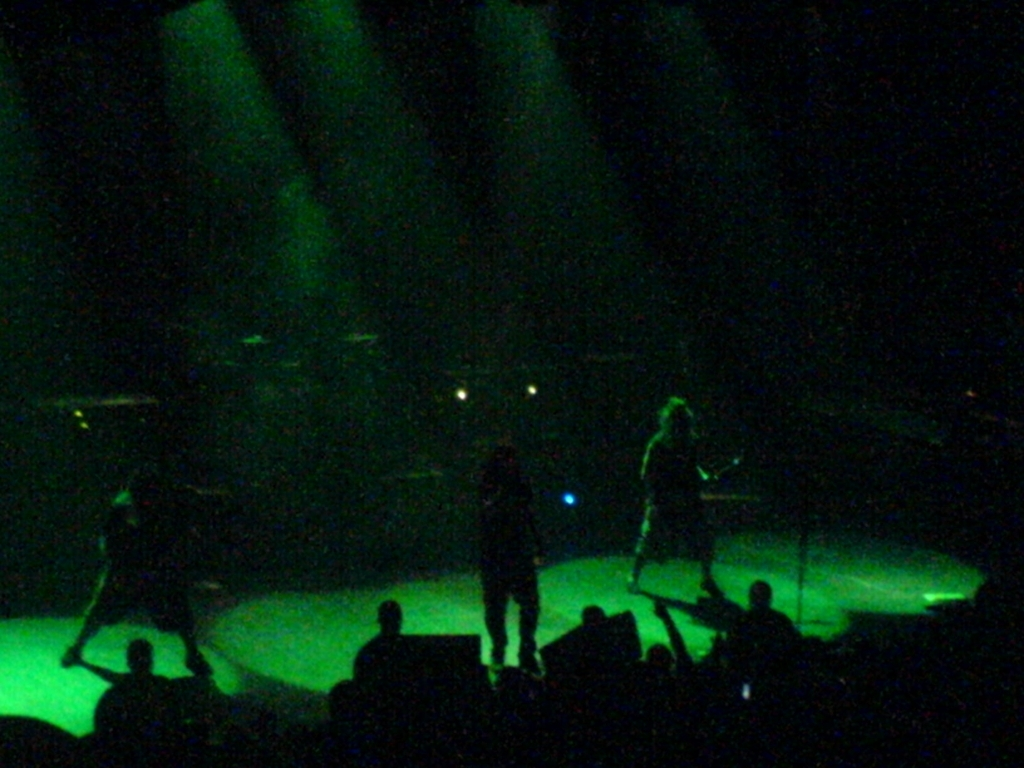Does the image have visible artifacts? While the image does not seem to have intentional artifacts, the photo quality appears grainy and has a high level of digital noise, likely due to low lighting conditions typical of concert settings, which can be considered as an artifact. 